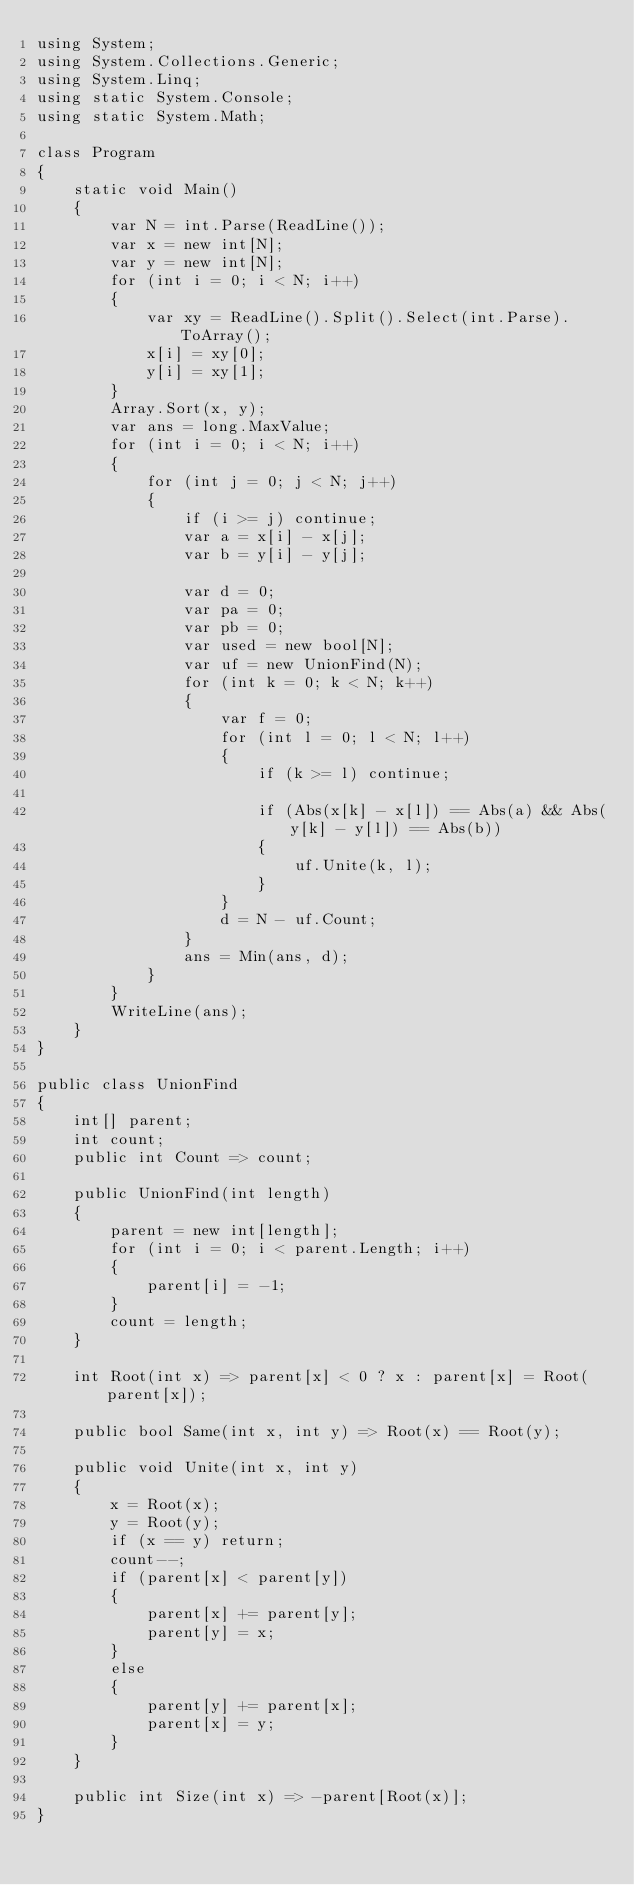Convert code to text. <code><loc_0><loc_0><loc_500><loc_500><_C#_>using System;
using System.Collections.Generic;
using System.Linq;
using static System.Console;
using static System.Math;

class Program
{
    static void Main()
    {
        var N = int.Parse(ReadLine());
        var x = new int[N];
        var y = new int[N];
        for (int i = 0; i < N; i++)
        {
            var xy = ReadLine().Split().Select(int.Parse).ToArray();
            x[i] = xy[0];
            y[i] = xy[1];
        }
        Array.Sort(x, y);
        var ans = long.MaxValue;
        for (int i = 0; i < N; i++)
        {
            for (int j = 0; j < N; j++)
            {
                if (i >= j) continue;
                var a = x[i] - x[j];
                var b = y[i] - y[j];

                var d = 0;
                var pa = 0;
                var pb = 0;
                var used = new bool[N];
                var uf = new UnionFind(N);
                for (int k = 0; k < N; k++)
                {
                    var f = 0;
                    for (int l = 0; l < N; l++)
                    {
                        if (k >= l) continue;

                        if (Abs(x[k] - x[l]) == Abs(a) && Abs(y[k] - y[l]) == Abs(b))
                        {
                            uf.Unite(k, l);
                        }
                    }
                    d = N - uf.Count;
                }
                ans = Min(ans, d);
            }
        }
        WriteLine(ans);
    }
}

public class UnionFind
{
    int[] parent;
    int count;
    public int Count => count;

    public UnionFind(int length)
    {
        parent = new int[length];
        for (int i = 0; i < parent.Length; i++)
        {
            parent[i] = -1;
        }
        count = length;
    }

    int Root(int x) => parent[x] < 0 ? x : parent[x] = Root(parent[x]);

    public bool Same(int x, int y) => Root(x) == Root(y);

    public void Unite(int x, int y)
    {
        x = Root(x);
        y = Root(y);
        if (x == y) return;
        count--;
        if (parent[x] < parent[y])
        {
            parent[x] += parent[y];
            parent[y] = x;
        }
        else
        {
            parent[y] += parent[x];
            parent[x] = y;
        }
    }

    public int Size(int x) => -parent[Root(x)];
}</code> 